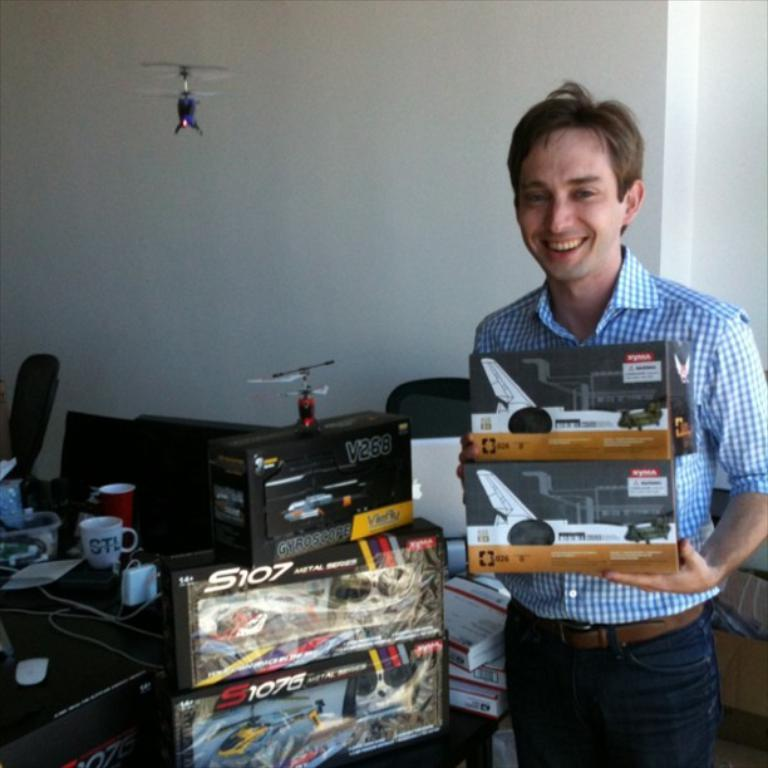<image>
Describe the image concisely. a happy man stands with models helicopters like the S107 